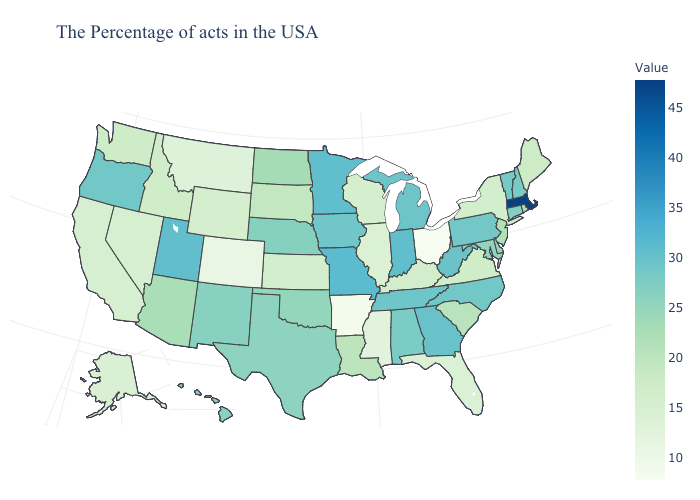Does Montana have a higher value than Maryland?
Short answer required. No. Which states have the highest value in the USA?
Short answer required. Massachusetts. Among the states that border Alabama , which have the highest value?
Quick response, please. Georgia. Among the states that border Idaho , which have the lowest value?
Write a very short answer. Montana. Does South Carolina have a lower value than Nevada?
Give a very brief answer. No. 